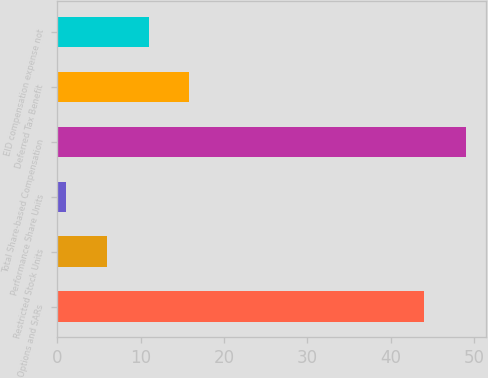Convert chart. <chart><loc_0><loc_0><loc_500><loc_500><bar_chart><fcel>Options and SARs<fcel>Restricted Stock Units<fcel>Performance Share Units<fcel>Total Share-based Compensation<fcel>Deferred Tax Benefit<fcel>EID compensation expense not<nl><fcel>44<fcel>6<fcel>1<fcel>49<fcel>15.8<fcel>11<nl></chart> 